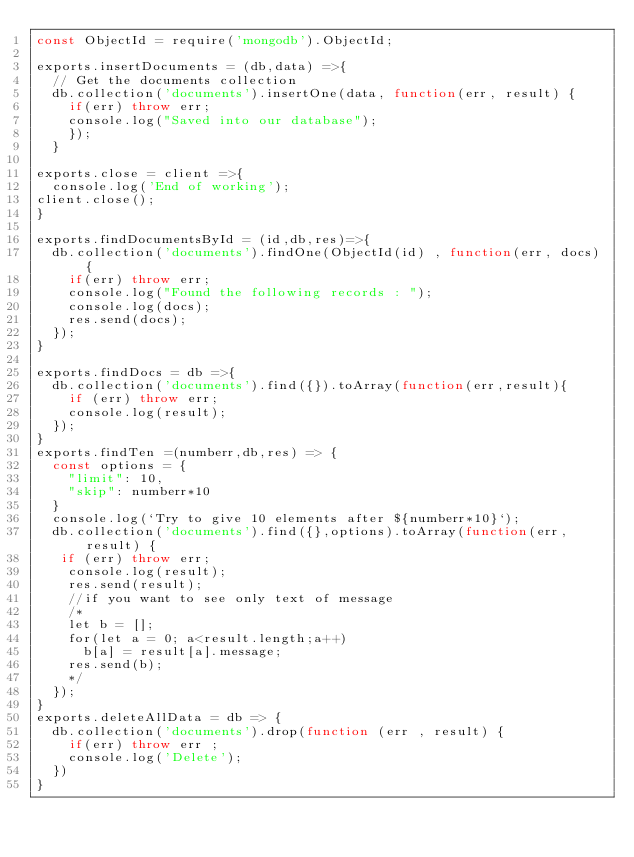Convert code to text. <code><loc_0><loc_0><loc_500><loc_500><_JavaScript_>const ObjectId = require('mongodb').ObjectId;

exports.insertDocuments = (db,data) =>{
  // Get the documents collection
  db.collection('documents').insertOne(data, function(err, result) {
    if(err) throw err;
    console.log("Saved into our database");
    });
  }

exports.close = client =>{
  console.log('End of working');
client.close();
}

exports.findDocumentsById = (id,db,res)=>{
  db.collection('documents').findOne(ObjectId(id) , function(err, docs) {
    if(err) throw err;
    console.log("Found the following records : ");
    console.log(docs);
    res.send(docs);
  });
}

exports.findDocs = db =>{
  db.collection('documents').find({}).toArray(function(err,result){
    if (err) throw err;
    console.log(result);
  });
}
exports.findTen =(numberr,db,res) => {
  const options = {
    "limit": 10,
    "skip": numberr*10
  }
  console.log(`Try to give 10 elements after ${numberr*10}`);
  db.collection('documents').find({},options).toArray(function(err, result) {
   if (err) throw err;
    console.log(result);
    res.send(result);
    //if you want to see only text of message
    /*
    let b = [];
    for(let a = 0; a<result.length;a++)
      b[a] = result[a].message;
    res.send(b);
    */
  });
}
exports.deleteAllData = db => {
  db.collection('documents').drop(function (err , result) {
    if(err) throw err ;
    console.log('Delete');
  })
}
</code> 